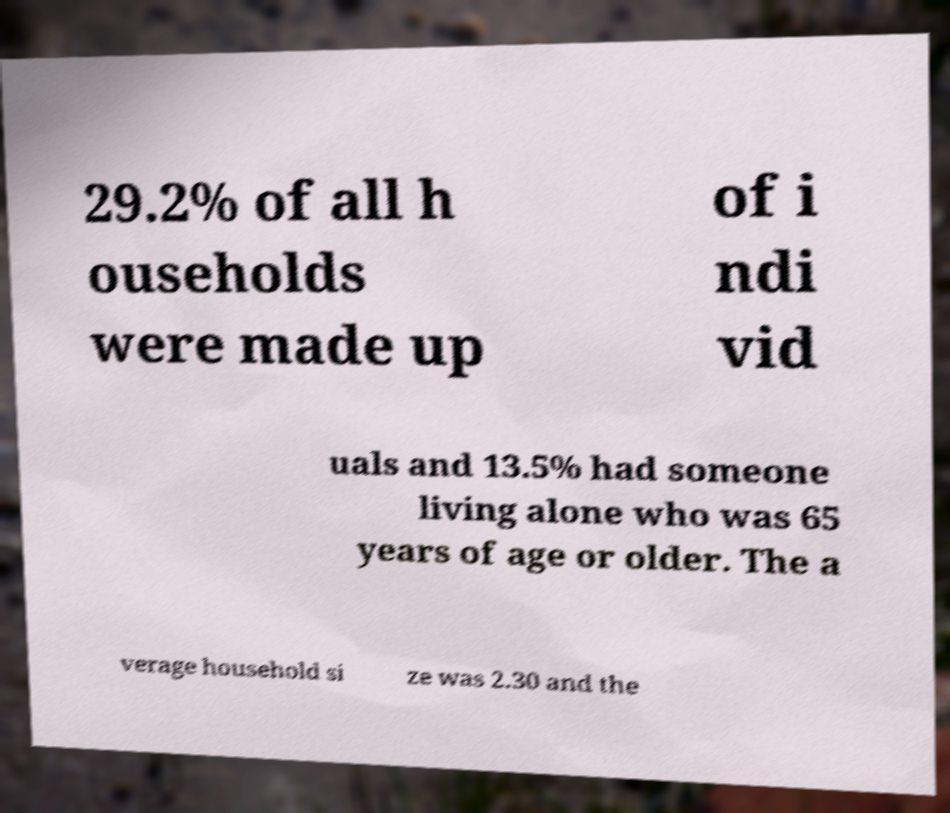What messages or text are displayed in this image? I need them in a readable, typed format. 29.2% of all h ouseholds were made up of i ndi vid uals and 13.5% had someone living alone who was 65 years of age or older. The a verage household si ze was 2.30 and the 